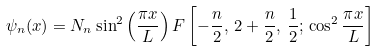Convert formula to latex. <formula><loc_0><loc_0><loc_500><loc_500>\psi _ { n } ( x ) = N _ { n } \sin ^ { 2 } \left ( \frac { \pi x } { L } \right ) F \left [ - \frac { n } { 2 } , \, 2 + \frac { n } { 2 } , \, \frac { 1 } { 2 } ; \, \cos ^ { 2 } \frac { \pi x } { L } \right ]</formula> 